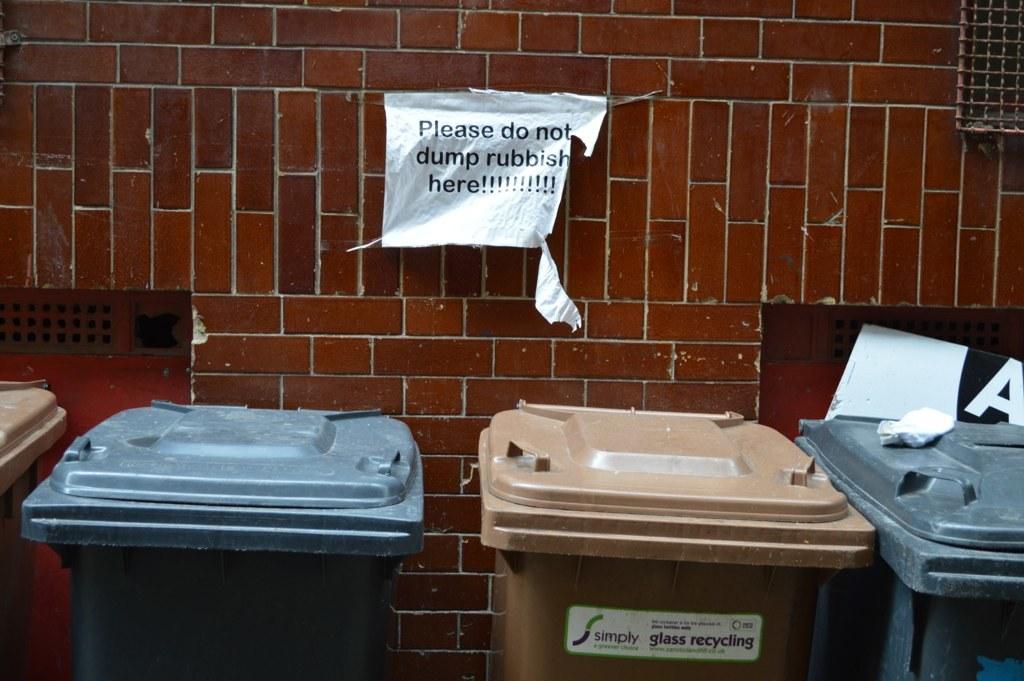Can we dump rubbish here?
Give a very brief answer. No. What type of recycling is the brown can for?
Give a very brief answer. Glass. 